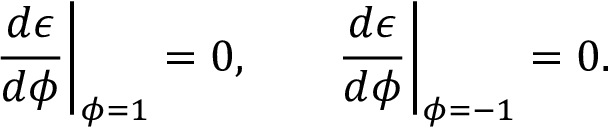<formula> <loc_0><loc_0><loc_500><loc_500>\frac { d \epsilon } { d \phi } \right | _ { \phi = 1 } = 0 , \quad \frac { d \epsilon } { d \phi } \right | _ { \phi = - 1 } = 0 .</formula> 